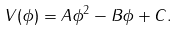Convert formula to latex. <formula><loc_0><loc_0><loc_500><loc_500>V ( \phi ) = A \phi ^ { 2 } - B \phi + C .</formula> 